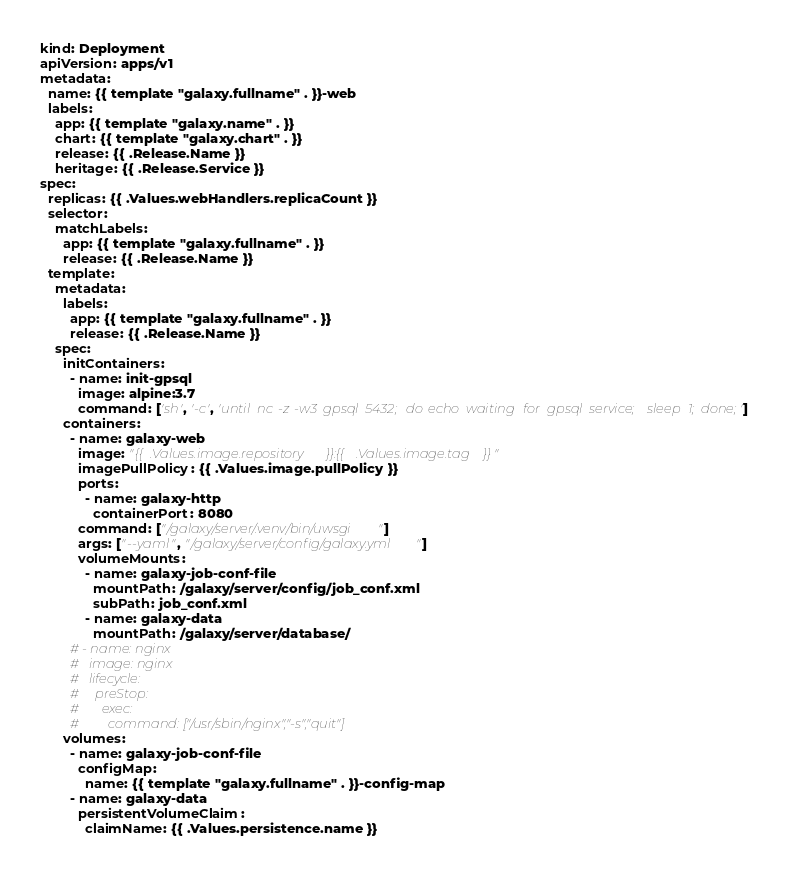Convert code to text. <code><loc_0><loc_0><loc_500><loc_500><_YAML_>kind: Deployment
apiVersion: apps/v1
metadata:
  name: {{ template "galaxy.fullname" . }}-web
  labels:
    app: {{ template "galaxy.name" . }}
    chart: {{ template "galaxy.chart" . }}
    release: {{ .Release.Name }}
    heritage: {{ .Release.Service }}
spec:
  replicas: {{ .Values.webHandlers.replicaCount }}
  selector:
    matchLabels:
      app: {{ template "galaxy.fullname" . }}
      release: {{ .Release.Name }}
  template:
    metadata:
      labels:
        app: {{ template "galaxy.fullname" . }}
        release: {{ .Release.Name }}
    spec:
      initContainers:
        - name: init-gpsql
          image: alpine:3.7
          command: ['sh', '-c', 'until nc -z -w3 gpsql 5432; do echo waiting for gpsql service; sleep 1; done;']
      containers:
        - name: galaxy-web
          image: "{{ .Values.image.repository }}:{{ .Values.image.tag }}"
          imagePullPolicy: {{ .Values.image.pullPolicy }}
          ports:
            - name: galaxy-http
              containerPort: 8080
          command: ["/galaxy/server/.venv/bin/uwsgi"]
          args: ["--yaml", "/galaxy/server/config/galaxy.yml"]
          volumeMounts:
            - name: galaxy-job-conf-file
              mountPath: /galaxy/server/config/job_conf.xml
              subPath: job_conf.xml
            - name: galaxy-data
              mountPath: /galaxy/server/database/
        # - name: nginx
        #   image: nginx
        #   lifecycle:
        #     preStop:
        #       exec:
        #         command: ["/usr/sbin/nginx","-s","quit"]
      volumes:
        - name: galaxy-job-conf-file
          configMap:
            name: {{ template "galaxy.fullname" . }}-config-map
        - name: galaxy-data
          persistentVolumeClaim:
            claimName: {{ .Values.persistence.name }}
</code> 